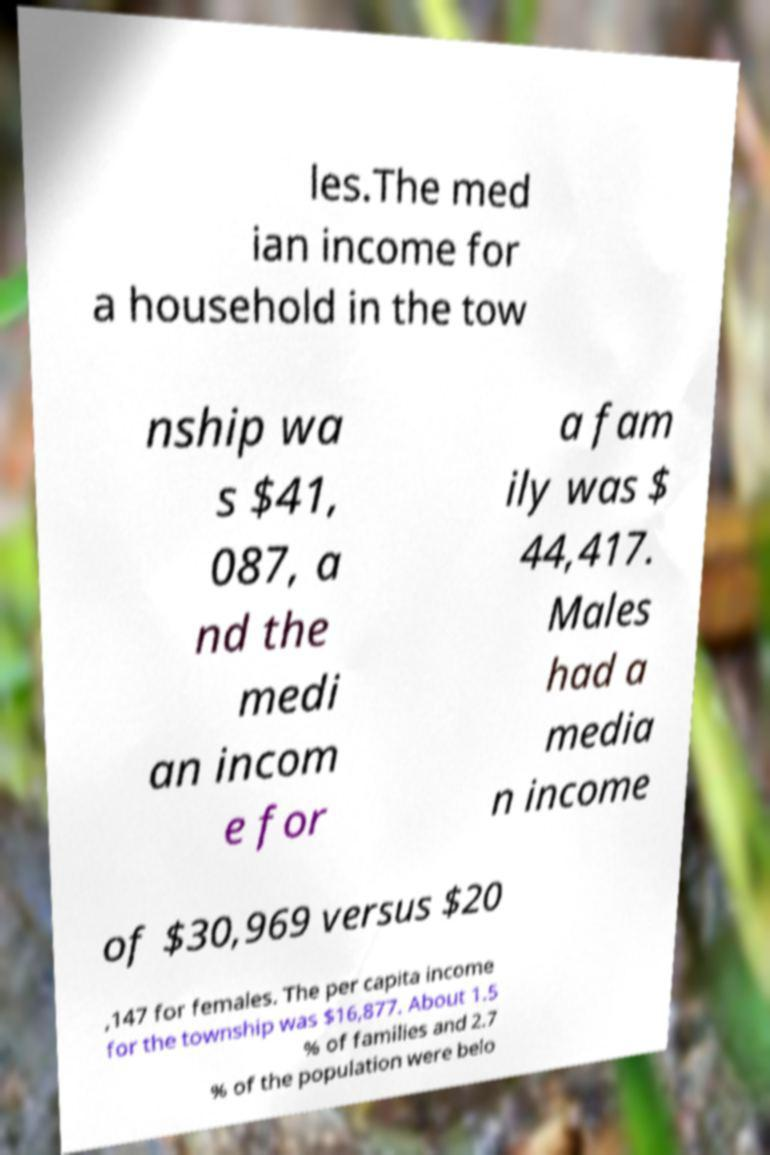Please identify and transcribe the text found in this image. les.The med ian income for a household in the tow nship wa s $41, 087, a nd the medi an incom e for a fam ily was $ 44,417. Males had a media n income of $30,969 versus $20 ,147 for females. The per capita income for the township was $16,877. About 1.5 % of families and 2.7 % of the population were belo 